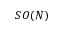Convert formula to latex. <formula><loc_0><loc_0><loc_500><loc_500>S O ( N )</formula> 